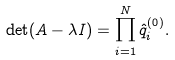Convert formula to latex. <formula><loc_0><loc_0><loc_500><loc_500>\det ( A - \lambda I ) = \prod _ { i = 1 } ^ { N } \hat { q } _ { i } ^ { ( 0 ) } .</formula> 